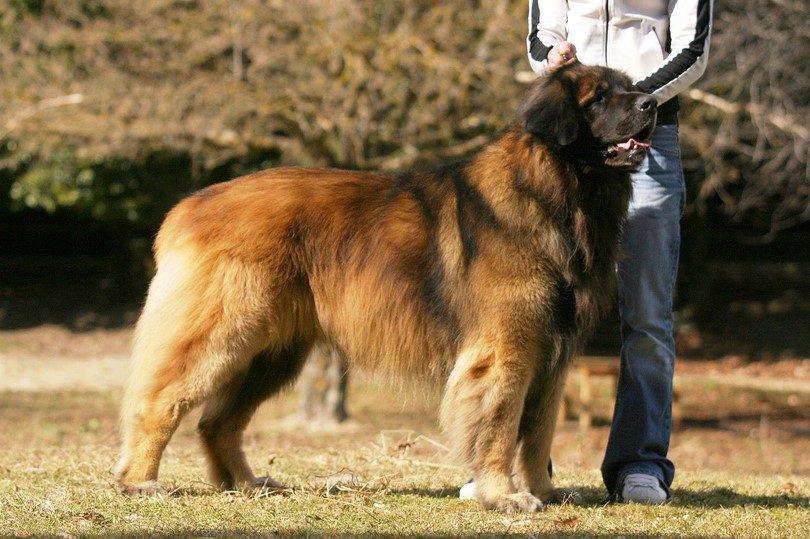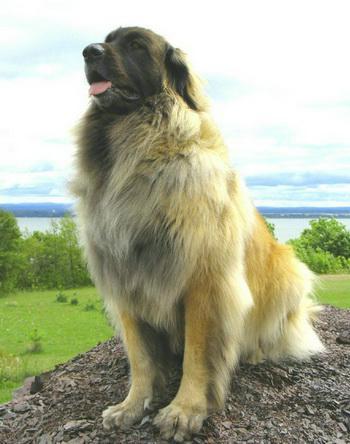The first image is the image on the left, the second image is the image on the right. For the images shown, is this caption "In one image, a woman in glasses is on the left of a dog that is sitting up, and the other image includes a dog standing in profile on grass." true? Answer yes or no. No. The first image is the image on the left, the second image is the image on the right. For the images displayed, is the sentence "There is a large body of water in the background of at least one of the pictures." factually correct? Answer yes or no. Yes. 